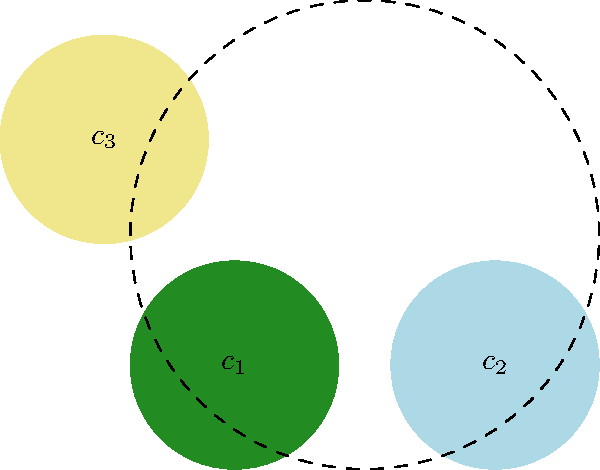In designing a cannabis-themed lounge, you're working with three colors: forest green ($c_1$), sky blue ($c_2$), and mellow yellow ($c_3$). These colors form a group under the operation of color mixing. If mixing any two colors always results in the third color, what is the group isomorphic to? Assume the group operation is commutative. Let's approach this step-by-step:

1) First, we need to understand the group structure:
   - There are 3 elements: $c_1$, $c_2$, and $c_3$
   - The operation (color mixing) is commutative
   - Mixing any two colors gives the third color

2) Let's write out the group table:
   $$\begin{array}{c|ccc}
   * & c_1 & c_2 & c_3 \\
   \hline
   c_1 & c_1 & c_3 & c_2 \\
   c_2 & c_3 & c_2 & c_1 \\
   c_3 & c_2 & c_1 & c_3
   \end{array}$$

3) Properties of this group:
   - It's closed (mixing always results in one of the three colors)
   - It's associative (as all color mixing is)
   - The identity element is each color mixed with itself
   - Each element is its own inverse

4) These properties, along with the group having 3 elements, uniquely define the group $\mathbb{Z}_3$, the cyclic group of order 3.

5) We can see the isomorphism by mapping:
   $c_1 \to 0$, $c_2 \to 1$, $c_3 \to 2$

   The operation in $\mathbb{Z}_3$ is addition modulo 3, which perfectly mimics our color mixing operation.

Therefore, this color mixing group is isomorphic to $\mathbb{Z}_3$.
Answer: $\mathbb{Z}_3$ 